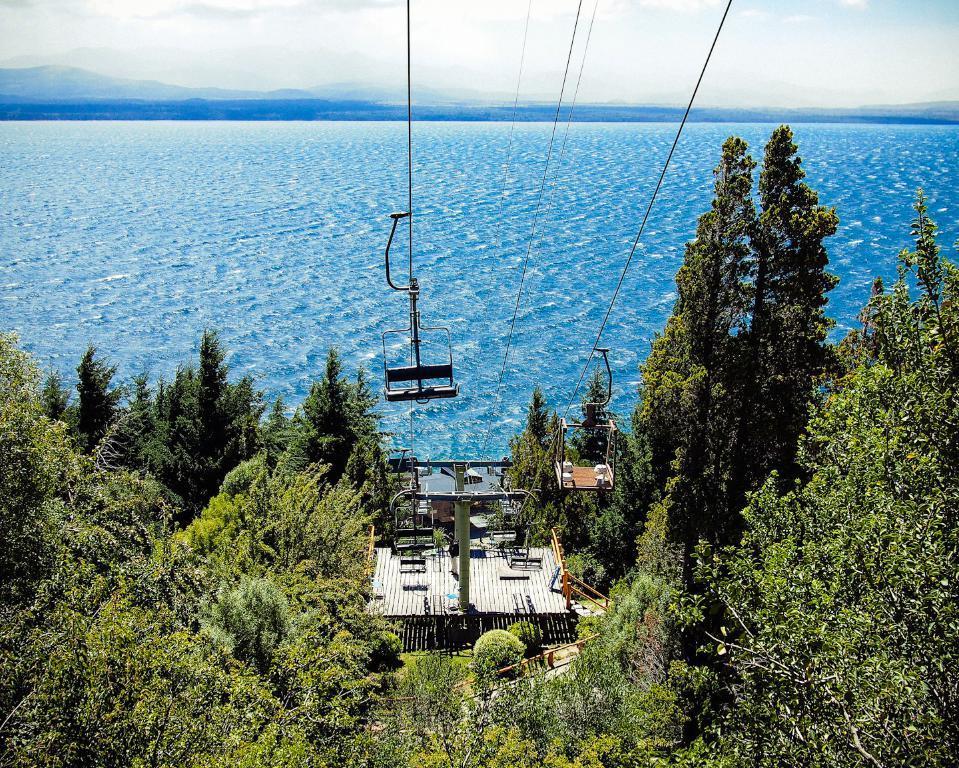Please provide a concise description of this image. In the image there is a wooden stage, beside that there is a railing and on the stage there are two poles and there are ropeways attached to the ropes and around the wooden stage there are trees, in the background there is a water surface. 